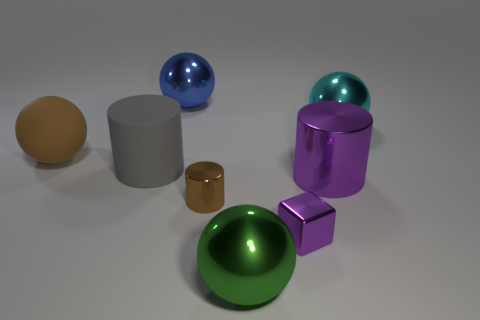Subtract all big cylinders. How many cylinders are left? 1 Add 1 large purple cylinders. How many objects exist? 9 Subtract all gray cylinders. How many cylinders are left? 2 Subtract 3 balls. How many balls are left? 1 Subtract all blocks. How many objects are left? 7 Add 3 tiny brown metal cylinders. How many tiny brown metal cylinders are left? 4 Add 1 cylinders. How many cylinders exist? 4 Subtract 0 cyan blocks. How many objects are left? 8 Subtract all red cylinders. Subtract all green spheres. How many cylinders are left? 3 Subtract all brown cubes. How many yellow cylinders are left? 0 